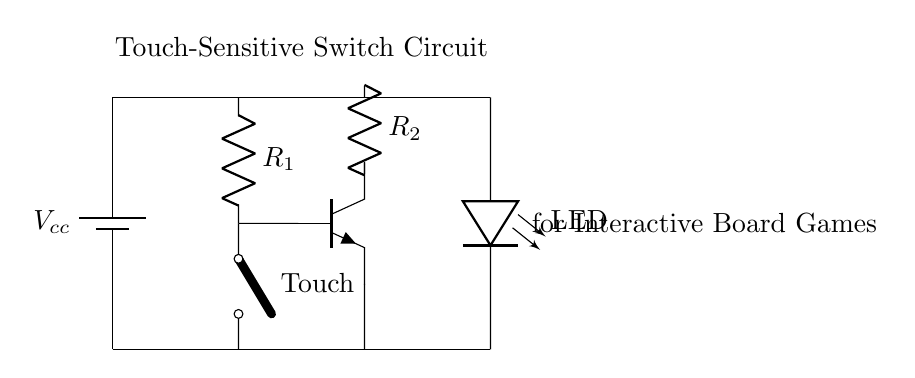What is the type of switch used in this circuit? The circuit diagram shows a "cute open switch," which indicates a touch-sensitive feature. This type of switch is activated by touch rather than by a mechanical action.
Answer: cute open switch What components are connected in series with the LED? The LED is connected in series with resistor R2. This is inferred from the wiring that shows both components share the same current path, meaning that they are lined up one after another.
Answer: R2 What is the role of the transistor in this circuit? The transistor functions as a switch that allows the current to flow to the LED when the touch sensor is activated. The base of the transistor is connected to the touch sensor, which controls the transistor's switching action.
Answer: Acts as a switch What is the significance of resistor R1 in this circuit? Resistor R1 is essential for limiting the current through the touch sensor to prevent it from drawing too much current when touched, ensuring proper functioning and longevity of the sensor.
Answer: Current limiting What happens when the touch sensor is activated? When the touch sensor is activated, it closes the circuit, allowing current to flow from the power supply through the transistor, which then turns on the LED. This indicates that the touch sensor has been successfully triggered.
Answer: LED lights up What voltage is supplied to the circuit? The circuit is supplied with a voltage labeled as Vcc, which is the power source voltage. While the exact value is not specified in the diagram, typically it would be a value compatible with the components being used, often 5V or 9V in similar applications.
Answer: Vcc 